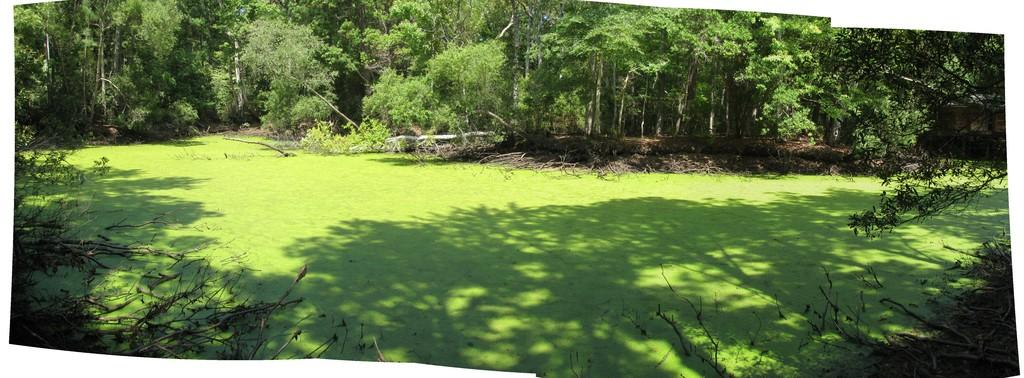What type of vegetation is in the front of the image? There are dry branches of a tree in the front of the image. What type of vegetation is on the ground in the center of the image? There is grass on the ground in the center of the image. What can be seen in the background of the image? There are trees and dry leaves in the background of the image. What is the wealth status of the trees in the image? The wealth status of the trees cannot be determined from the image, as trees do not have a wealth status. How does the temper of the dry leaves in the background affect the overall mood of the image? The temper of the dry leaves cannot be determined from the image, as leaves do not have a temper. 